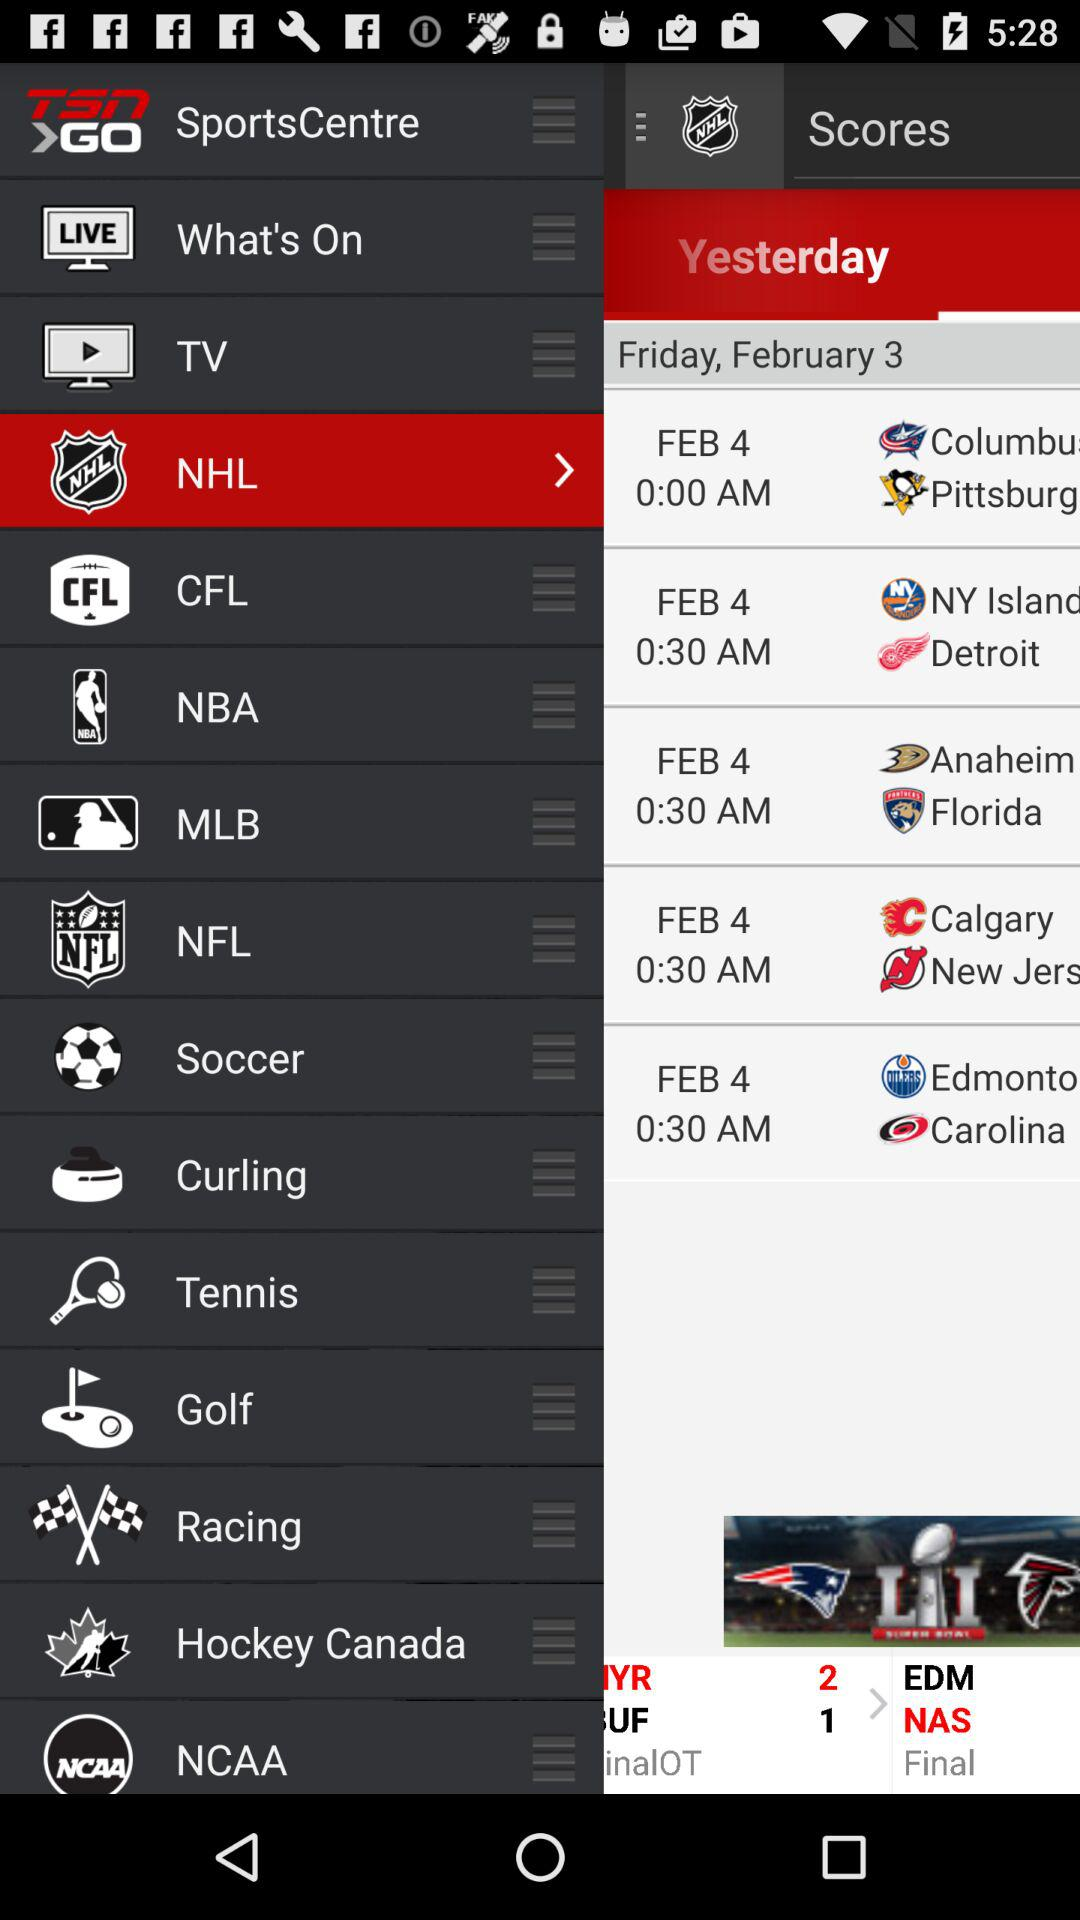Which date is shown on the screen?
When the provided information is insufficient, respond with <no answer>. <no answer> 